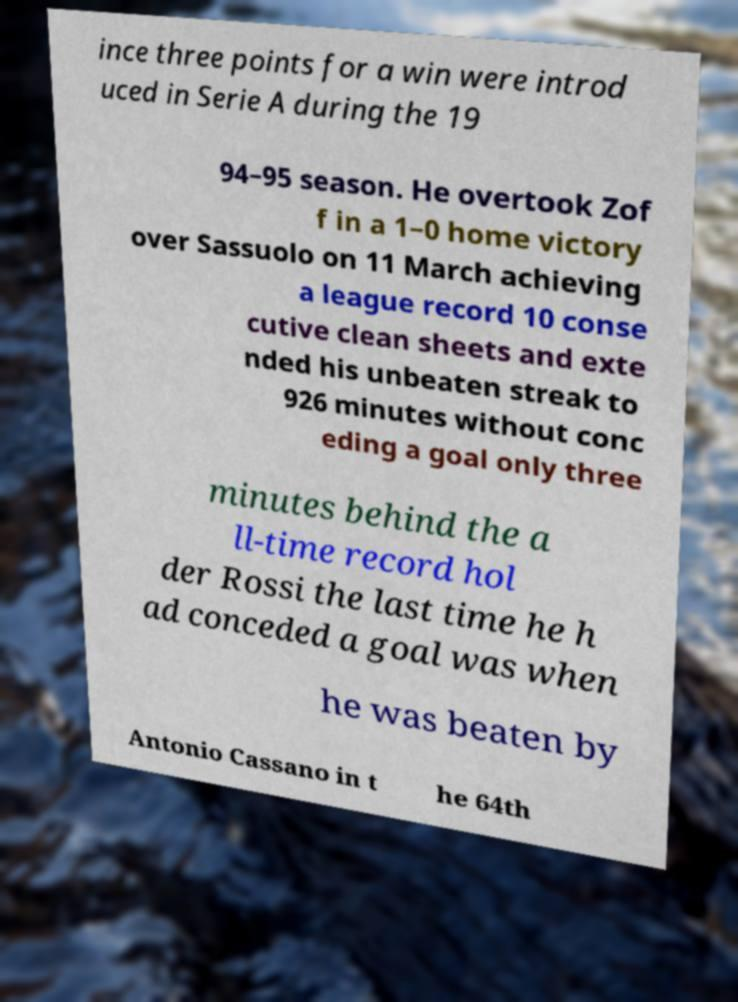For documentation purposes, I need the text within this image transcribed. Could you provide that? ince three points for a win were introd uced in Serie A during the 19 94–95 season. He overtook Zof f in a 1–0 home victory over Sassuolo on 11 March achieving a league record 10 conse cutive clean sheets and exte nded his unbeaten streak to 926 minutes without conc eding a goal only three minutes behind the a ll-time record hol der Rossi the last time he h ad conceded a goal was when he was beaten by Antonio Cassano in t he 64th 